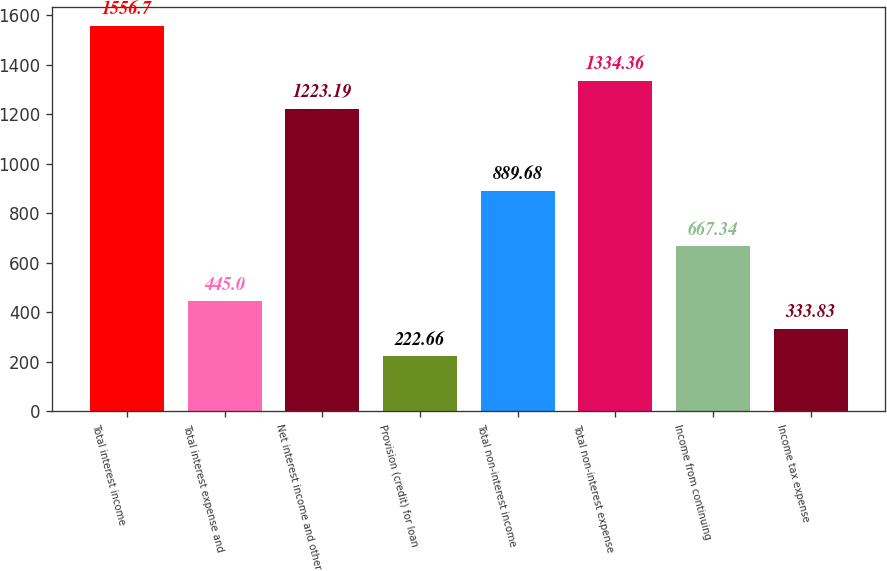Convert chart to OTSL. <chart><loc_0><loc_0><loc_500><loc_500><bar_chart><fcel>Total interest income<fcel>Total interest expense and<fcel>Net interest income and other<fcel>Provision (credit) for loan<fcel>Total non-interest income<fcel>Total non-interest expense<fcel>Income from continuing<fcel>Income tax expense<nl><fcel>1556.7<fcel>445<fcel>1223.19<fcel>222.66<fcel>889.68<fcel>1334.36<fcel>667.34<fcel>333.83<nl></chart> 